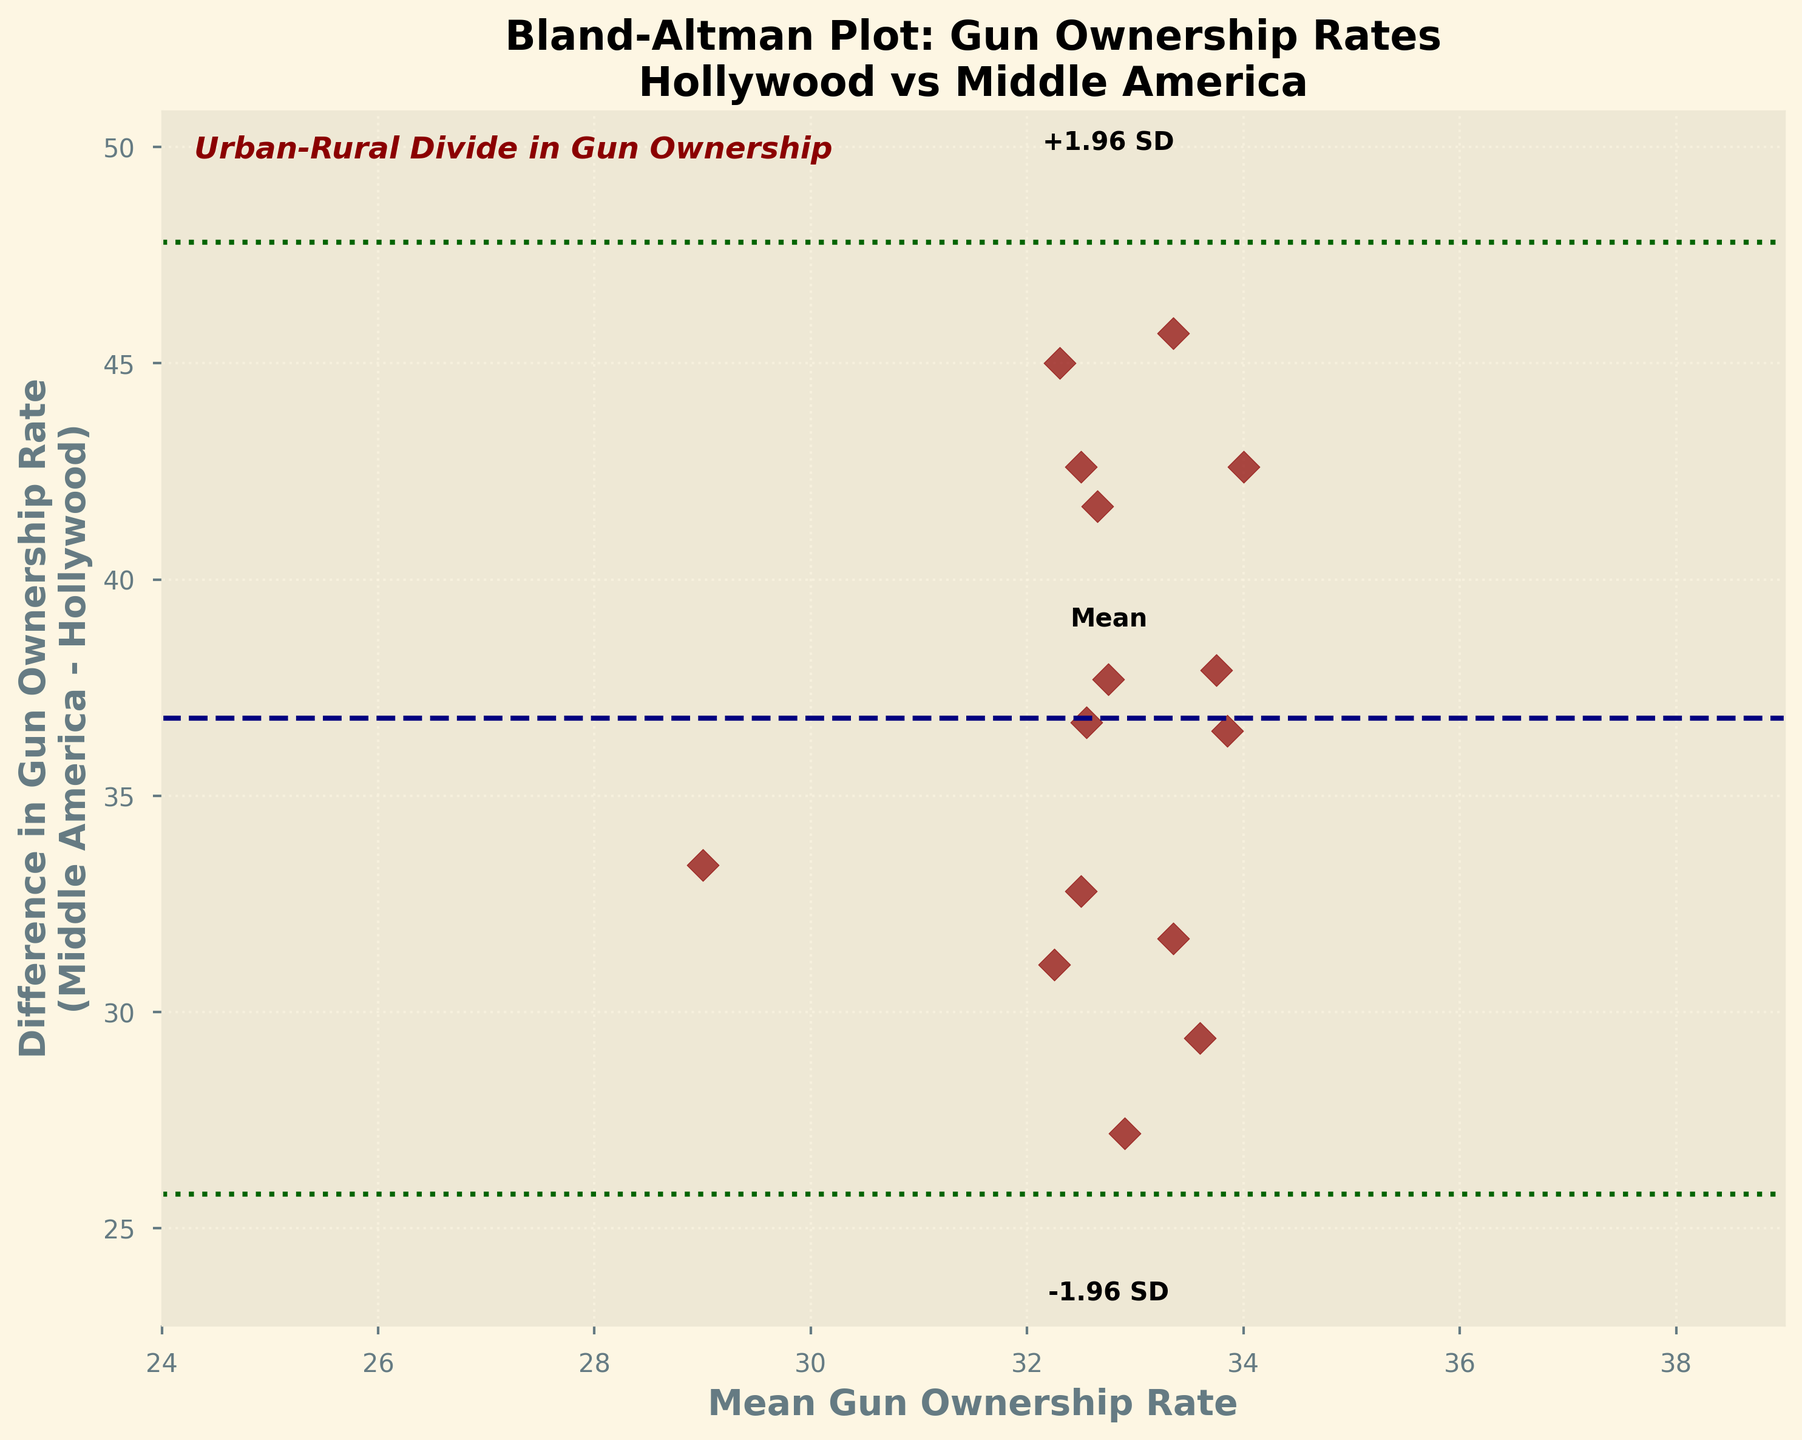What is the title of the plot? The title of the plot is located at the top of the figure. It reads "Bland-Altman Plot: Gun Ownership Rates Hollywood vs Middle America".
Answer: Bland-Altman Plot: Gun Ownership Rates Hollywood vs Middle America What is the label of the x-axis? The x-axis label can be found beneath the horizontal axis. It is written as "Mean Gun Ownership Rate".
Answer: Mean Gun Ownership Rate What is the color of the dashed line representing the mean difference? The dashed line that represents the mean difference is colored navy (or dark blue) in the plot.
Answer: Navy What gun ownership rate difference is represented by the horizontal lines marked "+1.96 SD" and "-1.96 SD"? The lines labeled "+1.96 SD" and "-1.96 SD" represent the mean difference plus and minus 1.96 times the standard deviation of the differences, respectively. These are indicated by the green dotted lines in the plot.
Answer: Mean plus/minus 1.96 SD What's the purpose of labeling "+1.96 SD", "Mean", and "-1.96 SD" on this plot? These labels indicate the central tendencies and variability around the mean difference in gun ownership rates. "+1.96 SD" shows the upper limit, "Mean" shows the central line of average difference, and "-1.96 SD" shows the lower limit, helping to understand the distribution.
Answer: To indicate central tendencies and variability Which region has a higher average gun ownership rate, Middle America or Hollywood? By observing the differences centered around the mean value on the plot, it is evident that Middle America consistently has higher gun ownership rates compared to Hollywood. This is supported by the consistently positive differences.
Answer: Middle America How many data points are plotted in total? To find the total number of data points, count the number of data markers (scatter points) visible on the plot. The data points reflect the differences in gun ownership rates between Hollywood and Middle America.
Answer: 15 Is there a general trend or pattern visible in the plot regarding gun ownership rates? By looking at the distribution of the scatter points, a trend where the differences between Middle America and Hollywood's gun ownership rates seem consistently above the mean difference can be observed. This suggests a consistent higher rate in Middle America.
Answer: Consistent higher rate in Middle America What do the vertical limits of the plot represent? The vertical limits of the plot represent the range of differences in gun ownership rates between Middle America and Hollywood. They cover the mean difference plus and minus 2.5 times the standard deviation of the differences.
Answer: Range of differences What is the y-axis labeled as, and what does it signify in this context? The y-axis is labeled "Difference in Gun Ownership Rate (Middle America - Hollywood)", and it signifies how much the gun ownership rate in Middle America differs from Hollywood for each data point.
Answer: Difference in Gun Ownership Rate (Middle America - Hollywood) 